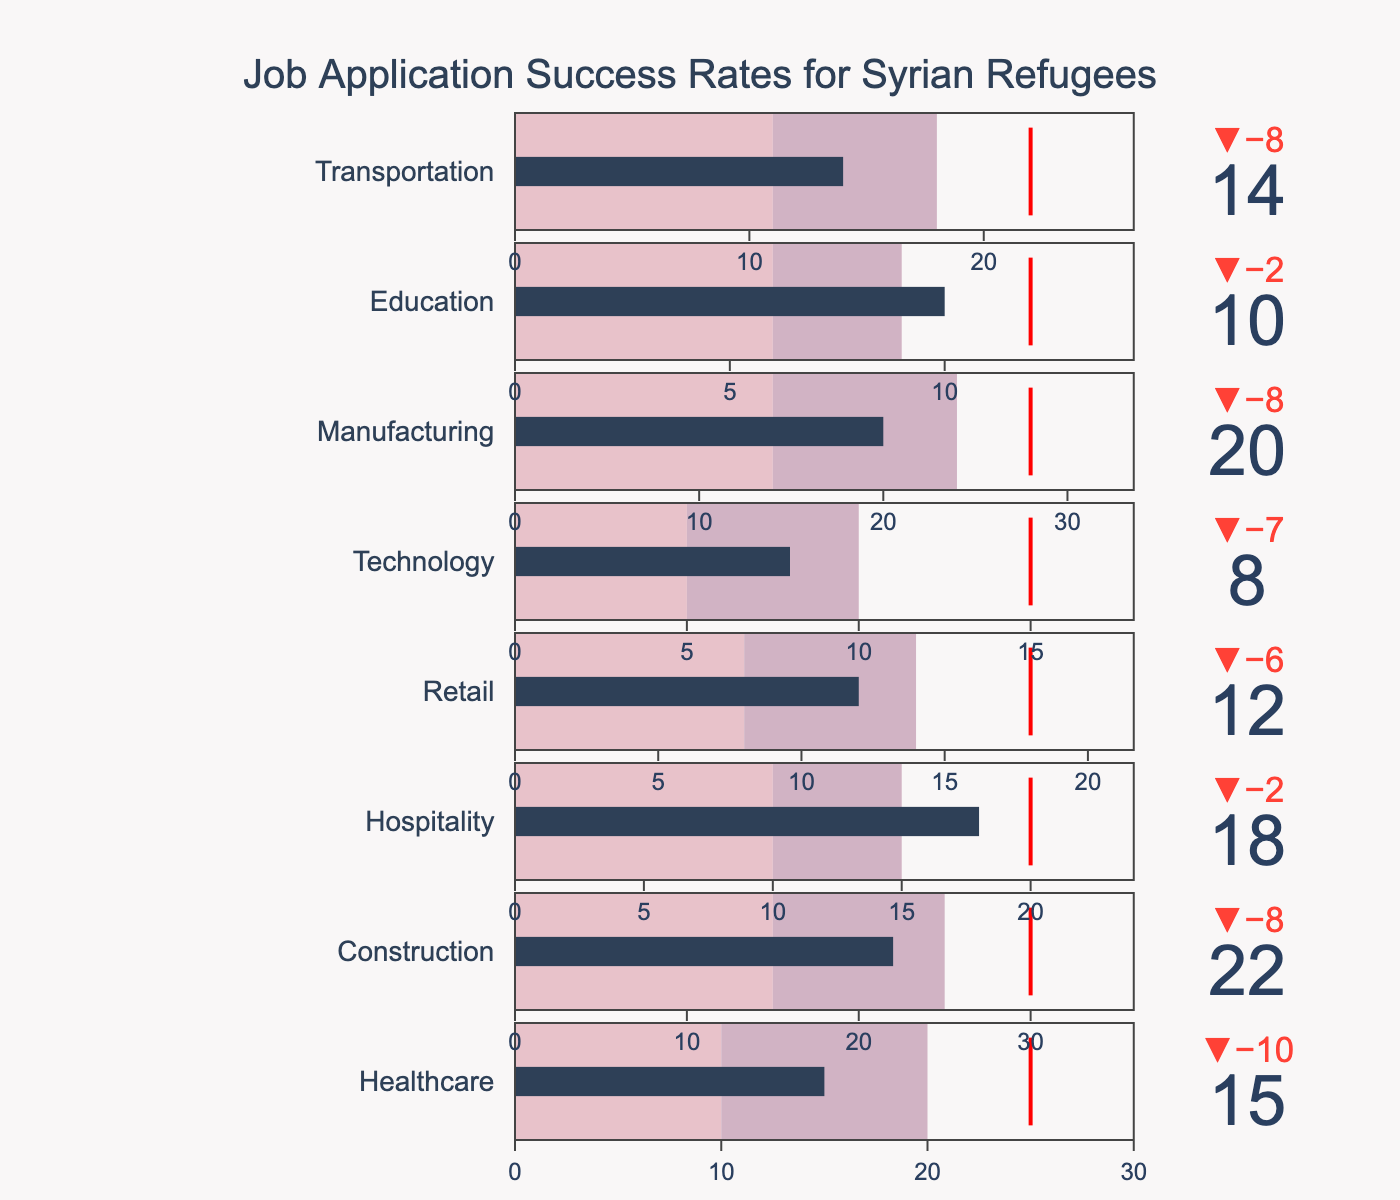What is the title of the figure? The title is prominently displayed at the top of the figure, providing an immediate summary of what the chart represents.
Answer: Job Application Success Rates for Syrian Refugees Which industry has the highest actual job application success rate? The height of the bars in each bullet chart segment indicates the success rates. The tallest bar corresponds to the actual success rate.
Answer: Construction What is the target job application success rate for the Technology sector? The target rate is represented by the red line in each bullet chart. By looking at the Technology section, we find the value next to the red line.
Answer: 15 Is the actual success rate for the Retail sector above or below its target? By comparing the bar height (actual success rate) with the position of the red threshold line (target), we can determine if it's above or below. In the Retail sector, the bar does not exceed the red line.
Answer: Below Which industry has the smallest gap between the actual success rate and the target? To find this, we need to compare the difference between the actual value (bar height) and the target value (red line) for each industry. The smallest gap is visually the smallest difference between these two points.
Answer: Healthcare What is the difference between the actual and target success rates in the Education sector? To calculate the difference, subtract the actual rate from the target rate in the Education sector. From the chart: 12 (target) - 10 (actual) = 2.
Answer: 2 In which industry is the actual success rate closest to the medium range (Range2)? The medium range is denoted by the middle color in the bullet chart. We need to find the industry where the bar height (actual success rate) is nearest to the middle segment of the colored range.
Answer: Hospitality Compare the actual success rates for Hospitality and Transportation sectors. Which one is higher? By examining the bar heights for both Hospitality and Transportation sectors, we can compare their actual success rates visually.
Answer: Hospitality Which industry sectors have actual success rates within Range3? Range3 is identified by the third color segment in each bullet chart. We look for industries where the bar height lies within this range.
Answer: Manufacturing, Transportation If you add the actual success rates of Healthcare, Construction, and Education, what is the sum? Summing the actual values for these sectors involves simple addition. From the chart: 15 (Healthcare) + 22 (Construction) + 10 (Education) = 47.
Answer: 47 